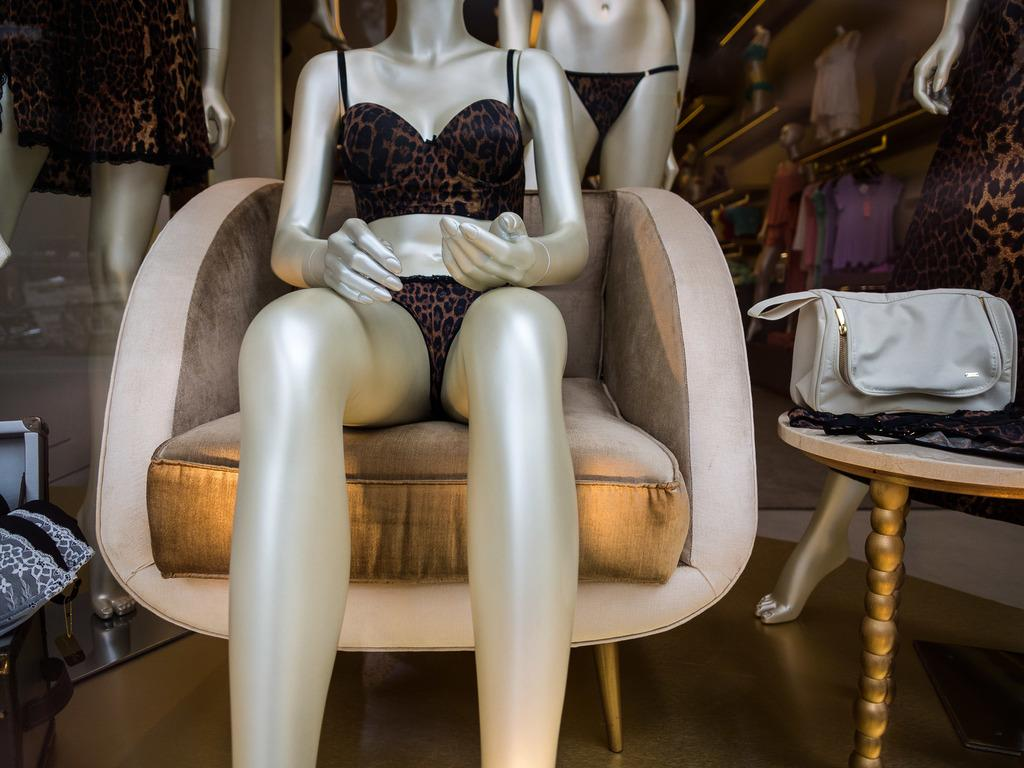What type of objects can be seen in the image? There are mannequins, a chair, a table, and a bag in the image. What else can be found in the image? There are clothes and racks in the background of the image. What is the setting of the image? The image shows a floor and a wall in the background. Can you see a monkey climbing on the wall in the image? No, there is no monkey present in the image. How many nails can be seen holding the bag to the wall in the image? There are no nails visible in the image, as the bag is not attached to the wall. 